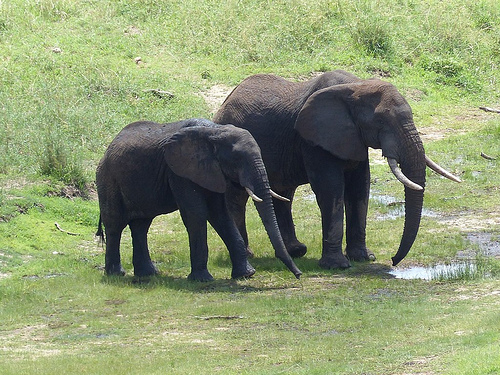Is the elephant that is not small drinking from a puddle? Yes, the large elephant is drinking from a puddle. 